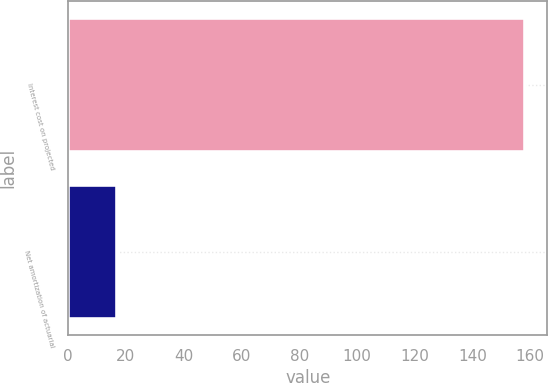Convert chart to OTSL. <chart><loc_0><loc_0><loc_500><loc_500><bar_chart><fcel>Interest cost on projected<fcel>Net amortization of actuarial<nl><fcel>158<fcel>17<nl></chart> 